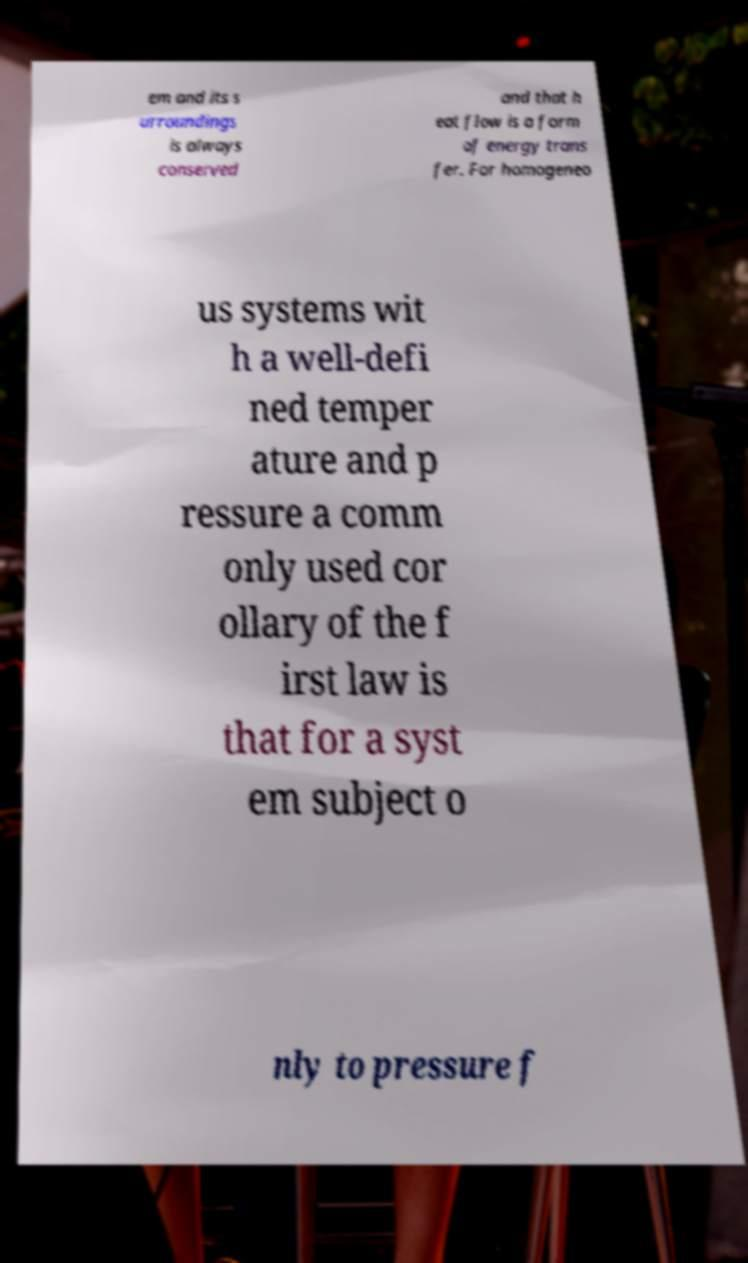For documentation purposes, I need the text within this image transcribed. Could you provide that? em and its s urroundings is always conserved and that h eat flow is a form of energy trans fer. For homogeneo us systems wit h a well-defi ned temper ature and p ressure a comm only used cor ollary of the f irst law is that for a syst em subject o nly to pressure f 